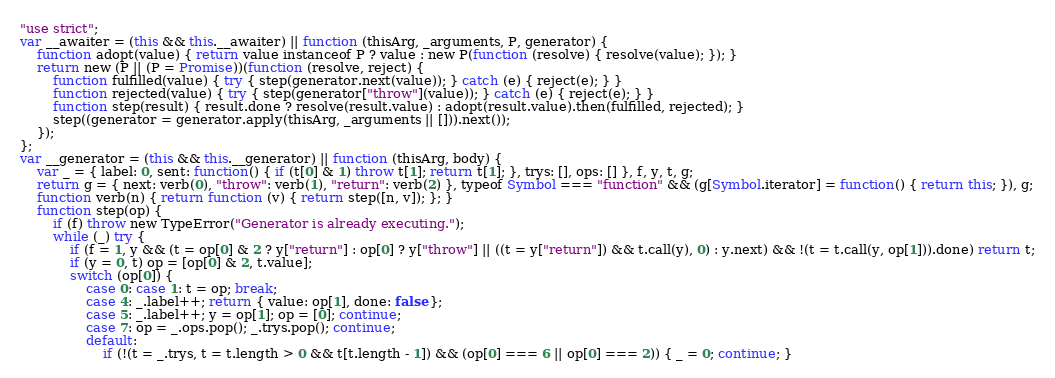<code> <loc_0><loc_0><loc_500><loc_500><_JavaScript_>"use strict";
var __awaiter = (this && this.__awaiter) || function (thisArg, _arguments, P, generator) {
    function adopt(value) { return value instanceof P ? value : new P(function (resolve) { resolve(value); }); }
    return new (P || (P = Promise))(function (resolve, reject) {
        function fulfilled(value) { try { step(generator.next(value)); } catch (e) { reject(e); } }
        function rejected(value) { try { step(generator["throw"](value)); } catch (e) { reject(e); } }
        function step(result) { result.done ? resolve(result.value) : adopt(result.value).then(fulfilled, rejected); }
        step((generator = generator.apply(thisArg, _arguments || [])).next());
    });
};
var __generator = (this && this.__generator) || function (thisArg, body) {
    var _ = { label: 0, sent: function() { if (t[0] & 1) throw t[1]; return t[1]; }, trys: [], ops: [] }, f, y, t, g;
    return g = { next: verb(0), "throw": verb(1), "return": verb(2) }, typeof Symbol === "function" && (g[Symbol.iterator] = function() { return this; }), g;
    function verb(n) { return function (v) { return step([n, v]); }; }
    function step(op) {
        if (f) throw new TypeError("Generator is already executing.");
        while (_) try {
            if (f = 1, y && (t = op[0] & 2 ? y["return"] : op[0] ? y["throw"] || ((t = y["return"]) && t.call(y), 0) : y.next) && !(t = t.call(y, op[1])).done) return t;
            if (y = 0, t) op = [op[0] & 2, t.value];
            switch (op[0]) {
                case 0: case 1: t = op; break;
                case 4: _.label++; return { value: op[1], done: false };
                case 5: _.label++; y = op[1]; op = [0]; continue;
                case 7: op = _.ops.pop(); _.trys.pop(); continue;
                default:
                    if (!(t = _.trys, t = t.length > 0 && t[t.length - 1]) && (op[0] === 6 || op[0] === 2)) { _ = 0; continue; }</code> 